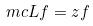Convert formula to latex. <formula><loc_0><loc_0><loc_500><loc_500>\ m c { L } f = z f</formula> 